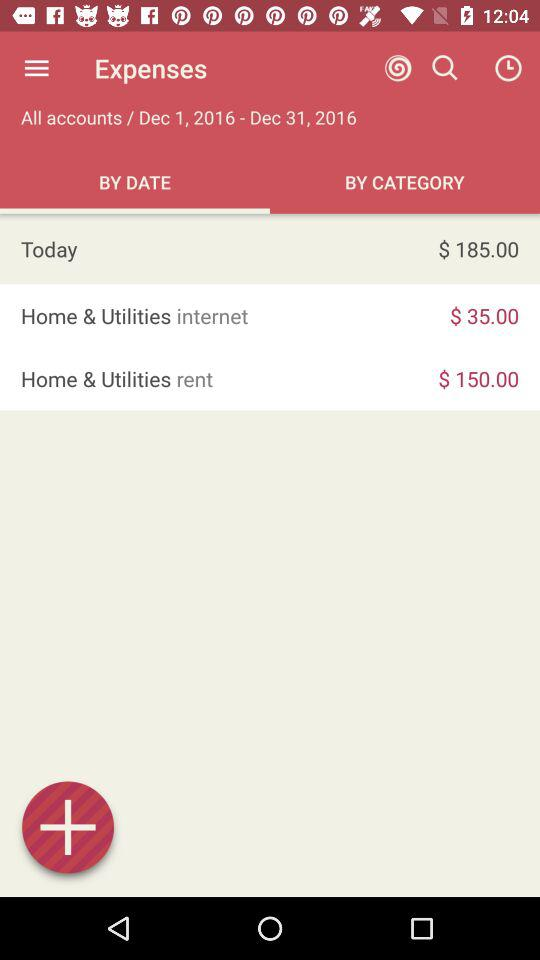What is the amount spent on the internet? The amount spent on the internet is $35.00. 